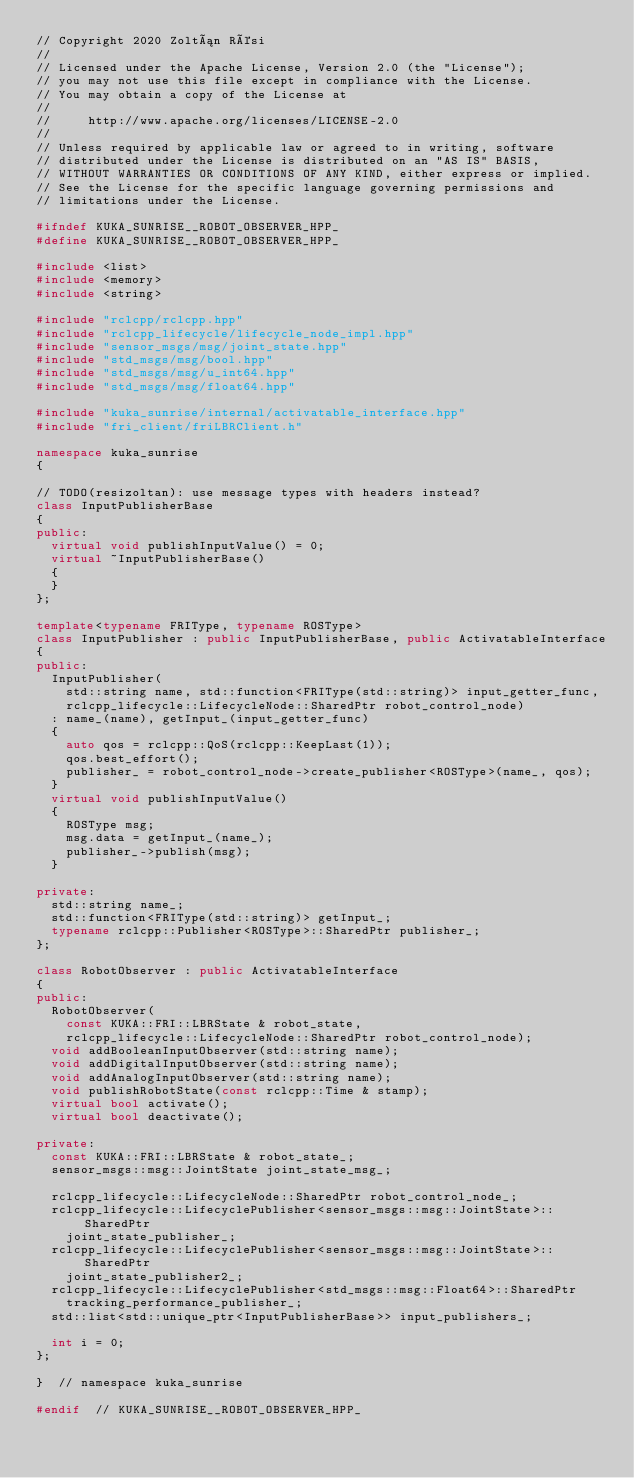<code> <loc_0><loc_0><loc_500><loc_500><_C++_>// Copyright 2020 Zoltán Rési
//
// Licensed under the Apache License, Version 2.0 (the "License");
// you may not use this file except in compliance with the License.
// You may obtain a copy of the License at
//
//     http://www.apache.org/licenses/LICENSE-2.0
//
// Unless required by applicable law or agreed to in writing, software
// distributed under the License is distributed on an "AS IS" BASIS,
// WITHOUT WARRANTIES OR CONDITIONS OF ANY KIND, either express or implied.
// See the License for the specific language governing permissions and
// limitations under the License.

#ifndef KUKA_SUNRISE__ROBOT_OBSERVER_HPP_
#define KUKA_SUNRISE__ROBOT_OBSERVER_HPP_

#include <list>
#include <memory>
#include <string>

#include "rclcpp/rclcpp.hpp"
#include "rclcpp_lifecycle/lifecycle_node_impl.hpp"
#include "sensor_msgs/msg/joint_state.hpp"
#include "std_msgs/msg/bool.hpp"
#include "std_msgs/msg/u_int64.hpp"
#include "std_msgs/msg/float64.hpp"

#include "kuka_sunrise/internal/activatable_interface.hpp"
#include "fri_client/friLBRClient.h"

namespace kuka_sunrise
{

// TODO(resizoltan): use message types with headers instead?
class InputPublisherBase
{
public:
  virtual void publishInputValue() = 0;
  virtual ~InputPublisherBase()
  {
  }
};

template<typename FRIType, typename ROSType>
class InputPublisher : public InputPublisherBase, public ActivatableInterface
{
public:
  InputPublisher(
    std::string name, std::function<FRIType(std::string)> input_getter_func,
    rclcpp_lifecycle::LifecycleNode::SharedPtr robot_control_node)
  : name_(name), getInput_(input_getter_func)
  {
    auto qos = rclcpp::QoS(rclcpp::KeepLast(1));
    qos.best_effort();
    publisher_ = robot_control_node->create_publisher<ROSType>(name_, qos);
  }
  virtual void publishInputValue()
  {
    ROSType msg;
    msg.data = getInput_(name_);
    publisher_->publish(msg);
  }

private:
  std::string name_;
  std::function<FRIType(std::string)> getInput_;
  typename rclcpp::Publisher<ROSType>::SharedPtr publisher_;
};

class RobotObserver : public ActivatableInterface
{
public:
  RobotObserver(
    const KUKA::FRI::LBRState & robot_state,
    rclcpp_lifecycle::LifecycleNode::SharedPtr robot_control_node);
  void addBooleanInputObserver(std::string name);
  void addDigitalInputObserver(std::string name);
  void addAnalogInputObserver(std::string name);
  void publishRobotState(const rclcpp::Time & stamp);
  virtual bool activate();
  virtual bool deactivate();

private:
  const KUKA::FRI::LBRState & robot_state_;
  sensor_msgs::msg::JointState joint_state_msg_;

  rclcpp_lifecycle::LifecycleNode::SharedPtr robot_control_node_;
  rclcpp_lifecycle::LifecyclePublisher<sensor_msgs::msg::JointState>::SharedPtr
    joint_state_publisher_;
  rclcpp_lifecycle::LifecyclePublisher<sensor_msgs::msg::JointState>::SharedPtr
    joint_state_publisher2_;
  rclcpp_lifecycle::LifecyclePublisher<std_msgs::msg::Float64>::SharedPtr
    tracking_performance_publisher_;
  std::list<std::unique_ptr<InputPublisherBase>> input_publishers_;

  int i = 0;
};

}  // namespace kuka_sunrise

#endif  // KUKA_SUNRISE__ROBOT_OBSERVER_HPP_
</code> 